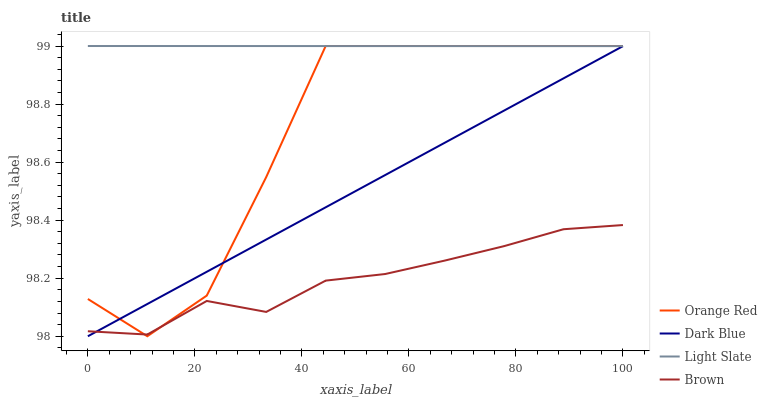Does Brown have the minimum area under the curve?
Answer yes or no. Yes. Does Light Slate have the maximum area under the curve?
Answer yes or no. Yes. Does Dark Blue have the minimum area under the curve?
Answer yes or no. No. Does Dark Blue have the maximum area under the curve?
Answer yes or no. No. Is Dark Blue the smoothest?
Answer yes or no. Yes. Is Orange Red the roughest?
Answer yes or no. Yes. Is Orange Red the smoothest?
Answer yes or no. No. Is Dark Blue the roughest?
Answer yes or no. No. Does Dark Blue have the lowest value?
Answer yes or no. Yes. Does Orange Red have the lowest value?
Answer yes or no. No. Does Orange Red have the highest value?
Answer yes or no. Yes. Does Dark Blue have the highest value?
Answer yes or no. No. Is Brown less than Light Slate?
Answer yes or no. Yes. Is Light Slate greater than Brown?
Answer yes or no. Yes. Does Brown intersect Dark Blue?
Answer yes or no. Yes. Is Brown less than Dark Blue?
Answer yes or no. No. Is Brown greater than Dark Blue?
Answer yes or no. No. Does Brown intersect Light Slate?
Answer yes or no. No. 